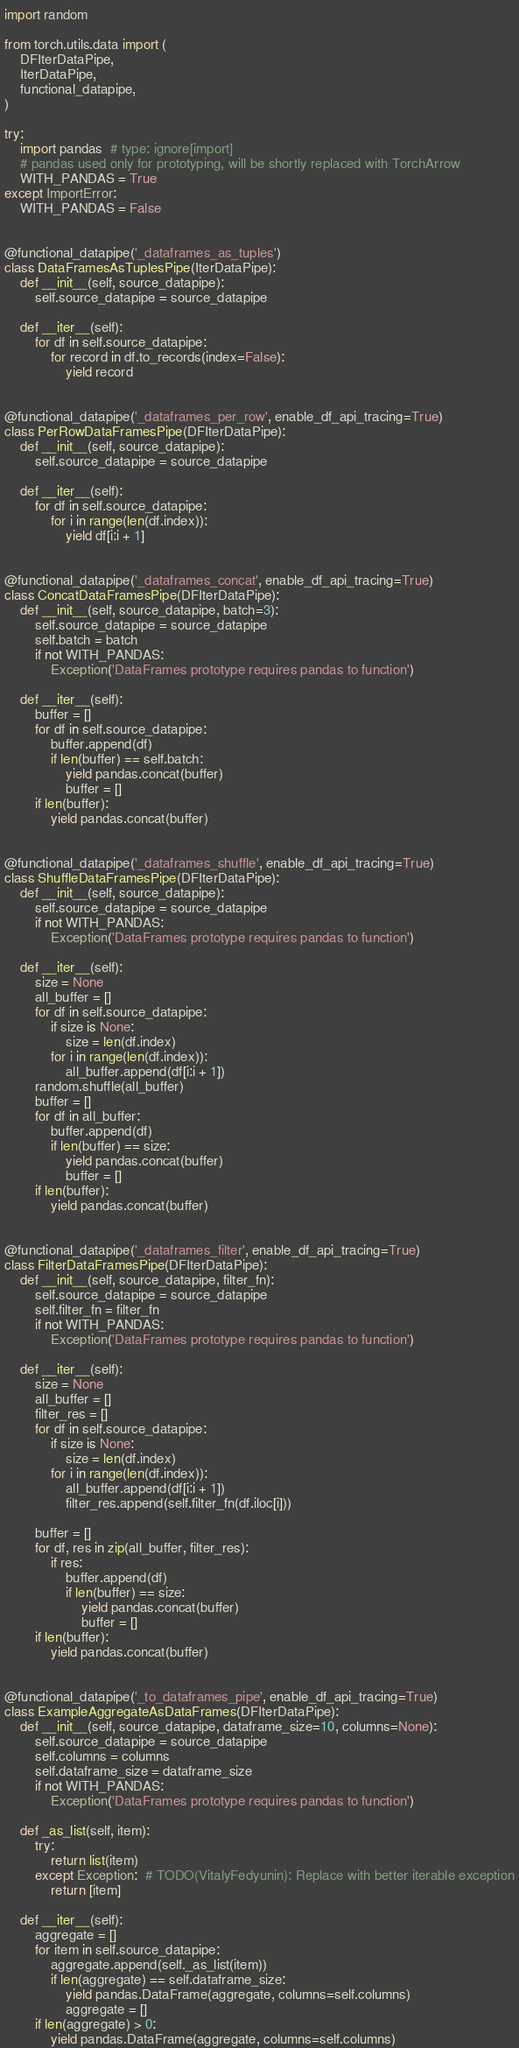<code> <loc_0><loc_0><loc_500><loc_500><_Python_>import random

from torch.utils.data import (
    DFIterDataPipe,
    IterDataPipe,
    functional_datapipe,
)

try:
    import pandas  # type: ignore[import]
    # pandas used only for prototyping, will be shortly replaced with TorchArrow
    WITH_PANDAS = True
except ImportError:
    WITH_PANDAS = False


@functional_datapipe('_dataframes_as_tuples')
class DataFramesAsTuplesPipe(IterDataPipe):
    def __init__(self, source_datapipe):
        self.source_datapipe = source_datapipe

    def __iter__(self):
        for df in self.source_datapipe:
            for record in df.to_records(index=False):
                yield record


@functional_datapipe('_dataframes_per_row', enable_df_api_tracing=True)
class PerRowDataFramesPipe(DFIterDataPipe):
    def __init__(self, source_datapipe):
        self.source_datapipe = source_datapipe

    def __iter__(self):
        for df in self.source_datapipe:
            for i in range(len(df.index)):
                yield df[i:i + 1]


@functional_datapipe('_dataframes_concat', enable_df_api_tracing=True)
class ConcatDataFramesPipe(DFIterDataPipe):
    def __init__(self, source_datapipe, batch=3):
        self.source_datapipe = source_datapipe
        self.batch = batch
        if not WITH_PANDAS:
            Exception('DataFrames prototype requires pandas to function')

    def __iter__(self):
        buffer = []
        for df in self.source_datapipe:
            buffer.append(df)
            if len(buffer) == self.batch:
                yield pandas.concat(buffer)
                buffer = []
        if len(buffer):
            yield pandas.concat(buffer)


@functional_datapipe('_dataframes_shuffle', enable_df_api_tracing=True)
class ShuffleDataFramesPipe(DFIterDataPipe):
    def __init__(self, source_datapipe):
        self.source_datapipe = source_datapipe
        if not WITH_PANDAS:
            Exception('DataFrames prototype requires pandas to function')

    def __iter__(self):
        size = None
        all_buffer = []
        for df in self.source_datapipe:
            if size is None:
                size = len(df.index)
            for i in range(len(df.index)):
                all_buffer.append(df[i:i + 1])
        random.shuffle(all_buffer)
        buffer = []
        for df in all_buffer:
            buffer.append(df)
            if len(buffer) == size:
                yield pandas.concat(buffer)
                buffer = []
        if len(buffer):
            yield pandas.concat(buffer)


@functional_datapipe('_dataframes_filter', enable_df_api_tracing=True)
class FilterDataFramesPipe(DFIterDataPipe):
    def __init__(self, source_datapipe, filter_fn):
        self.source_datapipe = source_datapipe
        self.filter_fn = filter_fn
        if not WITH_PANDAS:
            Exception('DataFrames prototype requires pandas to function')

    def __iter__(self):
        size = None
        all_buffer = []
        filter_res = []
        for df in self.source_datapipe:
            if size is None:
                size = len(df.index)
            for i in range(len(df.index)):
                all_buffer.append(df[i:i + 1])
                filter_res.append(self.filter_fn(df.iloc[i]))

        buffer = []
        for df, res in zip(all_buffer, filter_res):
            if res:
                buffer.append(df)
                if len(buffer) == size:
                    yield pandas.concat(buffer)
                    buffer = []
        if len(buffer):
            yield pandas.concat(buffer)


@functional_datapipe('_to_dataframes_pipe', enable_df_api_tracing=True)
class ExampleAggregateAsDataFrames(DFIterDataPipe):
    def __init__(self, source_datapipe, dataframe_size=10, columns=None):
        self.source_datapipe = source_datapipe
        self.columns = columns
        self.dataframe_size = dataframe_size
        if not WITH_PANDAS:
            Exception('DataFrames prototype requires pandas to function')

    def _as_list(self, item):
        try:
            return list(item)
        except Exception:  # TODO(VitalyFedyunin): Replace with better iterable exception
            return [item]

    def __iter__(self):
        aggregate = []
        for item in self.source_datapipe:
            aggregate.append(self._as_list(item))
            if len(aggregate) == self.dataframe_size:
                yield pandas.DataFrame(aggregate, columns=self.columns)
                aggregate = []
        if len(aggregate) > 0:
            yield pandas.DataFrame(aggregate, columns=self.columns)
</code> 